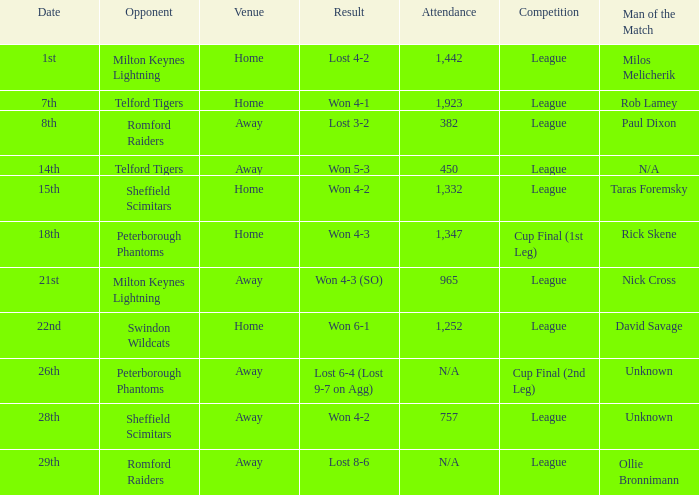What was the date when the attendance was n/a and the Man of the Match was unknown? 26th. 